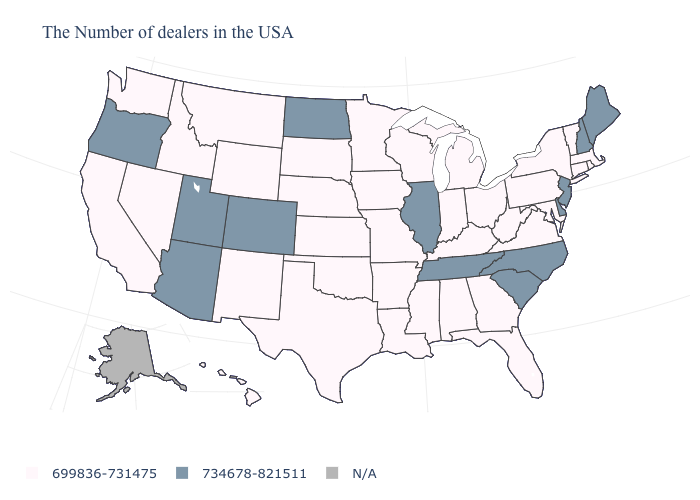Name the states that have a value in the range N/A?
Concise answer only. Alaska. Name the states that have a value in the range N/A?
Answer briefly. Alaska. Name the states that have a value in the range N/A?
Give a very brief answer. Alaska. Among the states that border Nebraska , does Colorado have the lowest value?
Give a very brief answer. No. How many symbols are there in the legend?
Keep it brief. 3. Which states have the lowest value in the South?
Keep it brief. Maryland, Virginia, West Virginia, Florida, Georgia, Kentucky, Alabama, Mississippi, Louisiana, Arkansas, Oklahoma, Texas. What is the value of New Hampshire?
Write a very short answer. 734678-821511. Which states have the lowest value in the MidWest?
Write a very short answer. Ohio, Michigan, Indiana, Wisconsin, Missouri, Minnesota, Iowa, Kansas, Nebraska, South Dakota. Name the states that have a value in the range 699836-731475?
Write a very short answer. Massachusetts, Rhode Island, Vermont, Connecticut, New York, Maryland, Pennsylvania, Virginia, West Virginia, Ohio, Florida, Georgia, Michigan, Kentucky, Indiana, Alabama, Wisconsin, Mississippi, Louisiana, Missouri, Arkansas, Minnesota, Iowa, Kansas, Nebraska, Oklahoma, Texas, South Dakota, Wyoming, New Mexico, Montana, Idaho, Nevada, California, Washington, Hawaii. What is the highest value in the Northeast ?
Quick response, please. 734678-821511. What is the value of Pennsylvania?
Be succinct. 699836-731475. What is the lowest value in the MidWest?
Be succinct. 699836-731475. Name the states that have a value in the range 699836-731475?
Quick response, please. Massachusetts, Rhode Island, Vermont, Connecticut, New York, Maryland, Pennsylvania, Virginia, West Virginia, Ohio, Florida, Georgia, Michigan, Kentucky, Indiana, Alabama, Wisconsin, Mississippi, Louisiana, Missouri, Arkansas, Minnesota, Iowa, Kansas, Nebraska, Oklahoma, Texas, South Dakota, Wyoming, New Mexico, Montana, Idaho, Nevada, California, Washington, Hawaii. Does New York have the lowest value in the Northeast?
Answer briefly. Yes. 